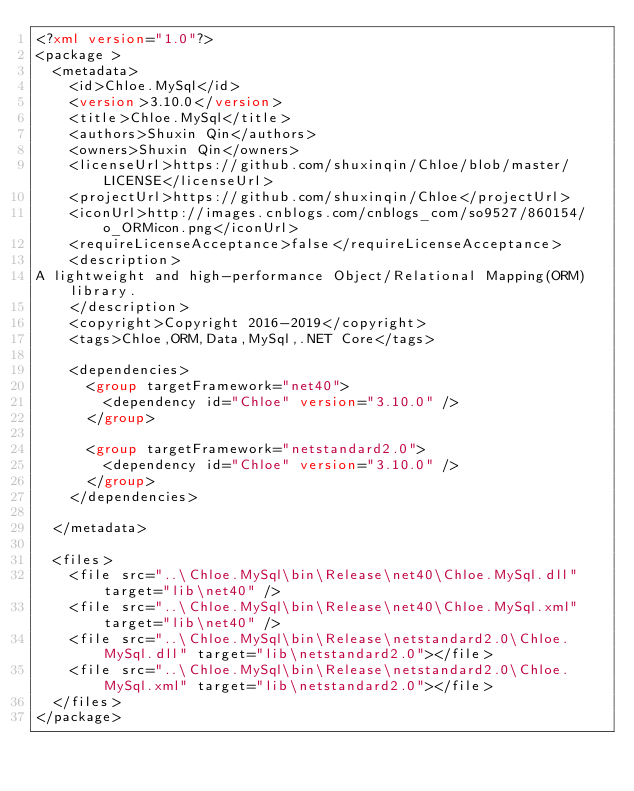Convert code to text. <code><loc_0><loc_0><loc_500><loc_500><_XML_><?xml version="1.0"?>
<package >
  <metadata>
    <id>Chloe.MySql</id>
    <version>3.10.0</version>
    <title>Chloe.MySql</title>
    <authors>Shuxin Qin</authors>
    <owners>Shuxin Qin</owners>
    <licenseUrl>https://github.com/shuxinqin/Chloe/blob/master/LICENSE</licenseUrl>
    <projectUrl>https://github.com/shuxinqin/Chloe</projectUrl>
    <iconUrl>http://images.cnblogs.com/cnblogs_com/so9527/860154/o_ORMicon.png</iconUrl>
    <requireLicenseAcceptance>false</requireLicenseAcceptance>
    <description>
A lightweight and high-performance Object/Relational Mapping(ORM) library.
    </description>
    <copyright>Copyright 2016-2019</copyright>
    <tags>Chloe,ORM,Data,MySql,.NET Core</tags>

    <dependencies>
      <group targetFramework="net40">
        <dependency id="Chloe" version="3.10.0" />	  
      </group>
	  
      <group targetFramework="netstandard2.0">
        <dependency id="Chloe" version="3.10.0" />
      </group> 
    </dependencies>
    
  </metadata>

  <files>
	<file src="..\Chloe.MySql\bin\Release\net40\Chloe.MySql.dll" target="lib\net40" />
    <file src="..\Chloe.MySql\bin\Release\net40\Chloe.MySql.xml" target="lib\net40" />
	<file src="..\Chloe.MySql\bin\Release\netstandard2.0\Chloe.MySql.dll" target="lib\netstandard2.0"></file>
    <file src="..\Chloe.MySql\bin\Release\netstandard2.0\Chloe.MySql.xml" target="lib\netstandard2.0"></file>
  </files>
</package></code> 